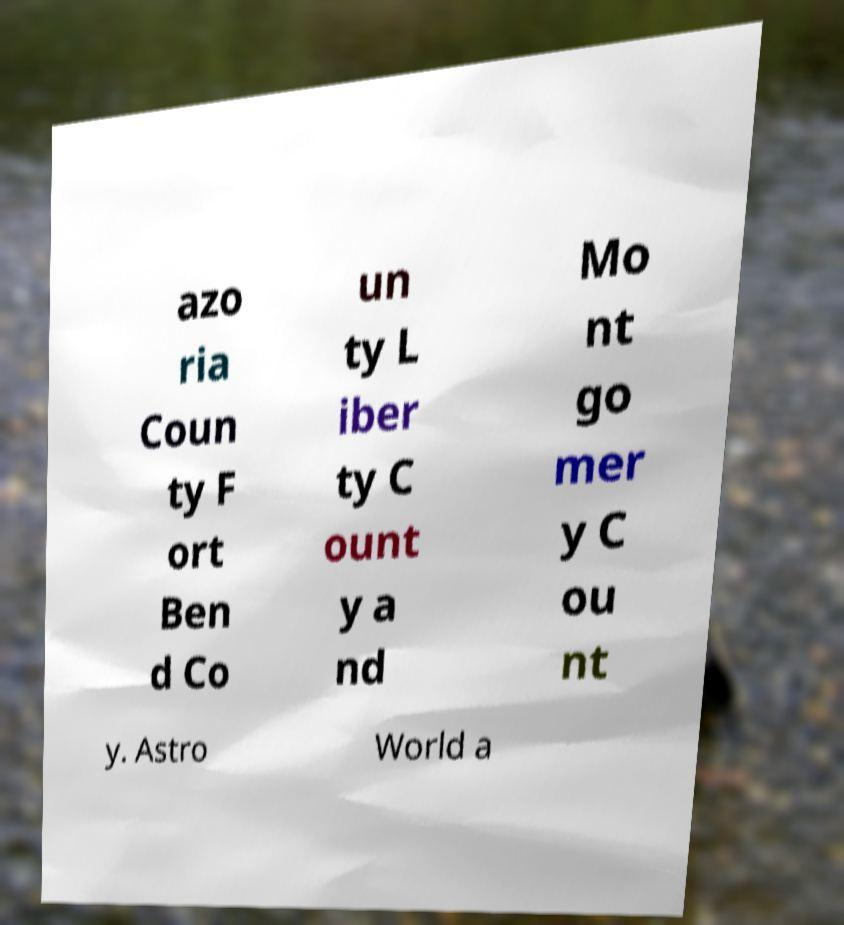What messages or text are displayed in this image? I need them in a readable, typed format. azo ria Coun ty F ort Ben d Co un ty L iber ty C ount y a nd Mo nt go mer y C ou nt y. Astro World a 